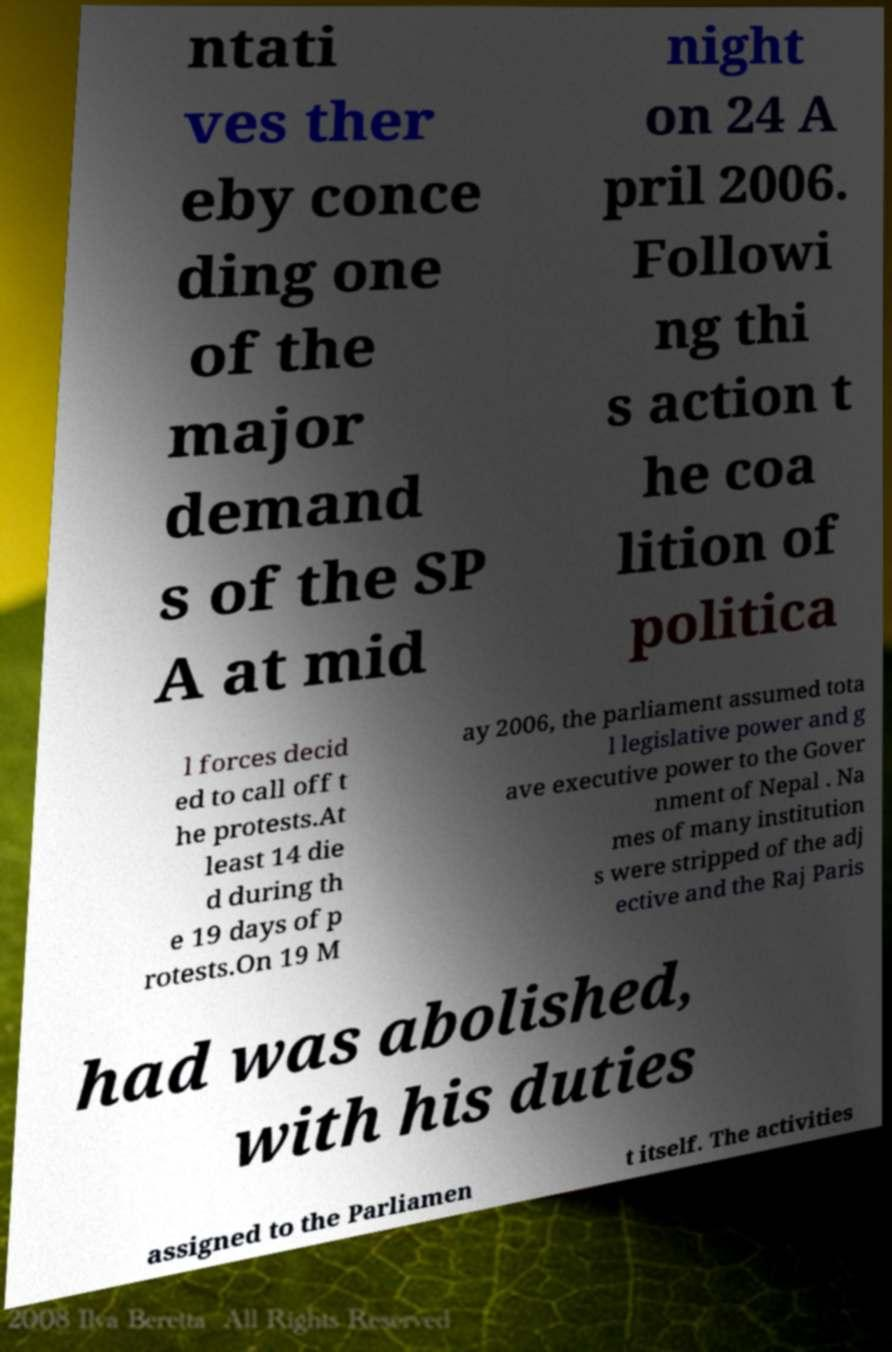Could you assist in decoding the text presented in this image and type it out clearly? ntati ves ther eby conce ding one of the major demand s of the SP A at mid night on 24 A pril 2006. Followi ng thi s action t he coa lition of politica l forces decid ed to call off t he protests.At least 14 die d during th e 19 days of p rotests.On 19 M ay 2006, the parliament assumed tota l legislative power and g ave executive power to the Gover nment of Nepal . Na mes of many institution s were stripped of the adj ective and the Raj Paris had was abolished, with his duties assigned to the Parliamen t itself. The activities 